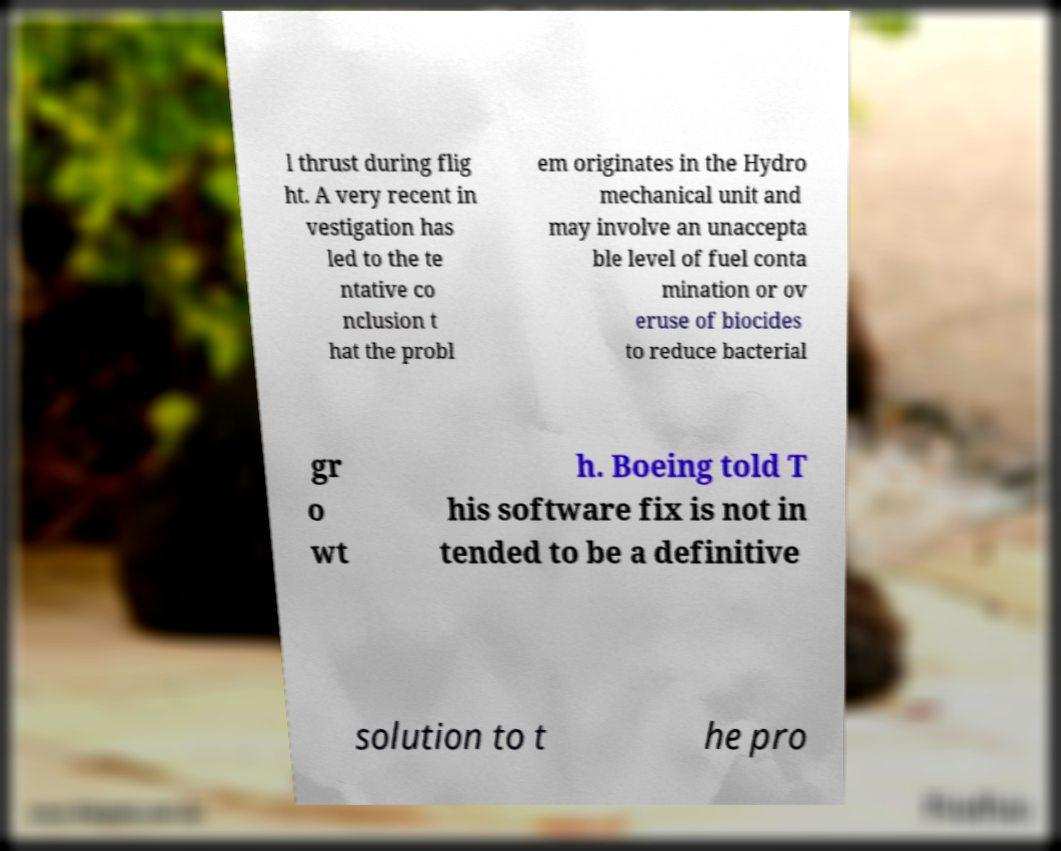Could you assist in decoding the text presented in this image and type it out clearly? l thrust during flig ht. A very recent in vestigation has led to the te ntative co nclusion t hat the probl em originates in the Hydro mechanical unit and may involve an unaccepta ble level of fuel conta mination or ov eruse of biocides to reduce bacterial gr o wt h. Boeing told T his software fix is not in tended to be a definitive solution to t he pro 